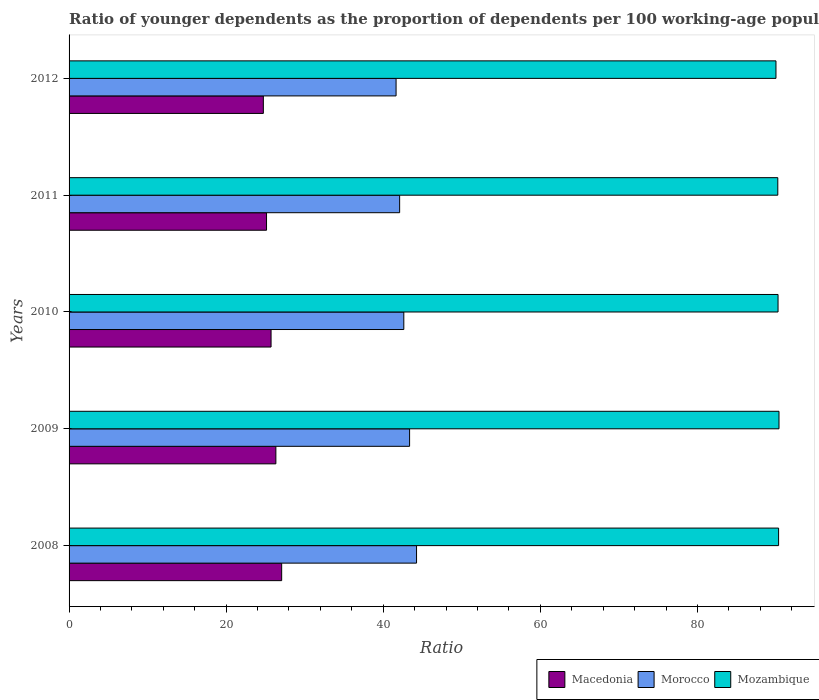How many different coloured bars are there?
Ensure brevity in your answer.  3. How many groups of bars are there?
Keep it short and to the point. 5. Are the number of bars on each tick of the Y-axis equal?
Your response must be concise. Yes. How many bars are there on the 5th tick from the top?
Ensure brevity in your answer.  3. How many bars are there on the 5th tick from the bottom?
Provide a succinct answer. 3. What is the label of the 4th group of bars from the top?
Ensure brevity in your answer.  2009. What is the age dependency ratio(young) in Mozambique in 2011?
Your answer should be compact. 90.23. Across all years, what is the maximum age dependency ratio(young) in Mozambique?
Give a very brief answer. 90.39. Across all years, what is the minimum age dependency ratio(young) in Morocco?
Provide a succinct answer. 41.63. In which year was the age dependency ratio(young) in Macedonia maximum?
Your answer should be very brief. 2008. What is the total age dependency ratio(young) in Macedonia in the graph?
Give a very brief answer. 128.99. What is the difference between the age dependency ratio(young) in Mozambique in 2009 and that in 2011?
Provide a succinct answer. 0.15. What is the difference between the age dependency ratio(young) in Macedonia in 2010 and the age dependency ratio(young) in Mozambique in 2008?
Offer a very short reply. -64.62. What is the average age dependency ratio(young) in Mozambique per year?
Offer a very short reply. 90.24. In the year 2012, what is the difference between the age dependency ratio(young) in Morocco and age dependency ratio(young) in Mozambique?
Your answer should be very brief. -48.37. What is the ratio of the age dependency ratio(young) in Macedonia in 2011 to that in 2012?
Make the answer very short. 1.02. Is the age dependency ratio(young) in Morocco in 2010 less than that in 2012?
Keep it short and to the point. No. Is the difference between the age dependency ratio(young) in Morocco in 2009 and 2010 greater than the difference between the age dependency ratio(young) in Mozambique in 2009 and 2010?
Give a very brief answer. Yes. What is the difference between the highest and the second highest age dependency ratio(young) in Morocco?
Your answer should be compact. 0.89. What is the difference between the highest and the lowest age dependency ratio(young) in Morocco?
Your response must be concise. 2.61. Is the sum of the age dependency ratio(young) in Morocco in 2008 and 2010 greater than the maximum age dependency ratio(young) in Macedonia across all years?
Your answer should be very brief. Yes. What does the 1st bar from the top in 2011 represents?
Keep it short and to the point. Mozambique. What does the 2nd bar from the bottom in 2008 represents?
Ensure brevity in your answer.  Morocco. What is the difference between two consecutive major ticks on the X-axis?
Provide a short and direct response. 20. Are the values on the major ticks of X-axis written in scientific E-notation?
Your response must be concise. No. Does the graph contain any zero values?
Provide a succinct answer. No. What is the title of the graph?
Provide a succinct answer. Ratio of younger dependents as the proportion of dependents per 100 working-age population. Does "Papua New Guinea" appear as one of the legend labels in the graph?
Ensure brevity in your answer.  No. What is the label or title of the X-axis?
Give a very brief answer. Ratio. What is the label or title of the Y-axis?
Make the answer very short. Years. What is the Ratio of Macedonia in 2008?
Your answer should be very brief. 27.07. What is the Ratio of Morocco in 2008?
Ensure brevity in your answer.  44.24. What is the Ratio in Mozambique in 2008?
Provide a succinct answer. 90.33. What is the Ratio in Macedonia in 2009?
Your answer should be very brief. 26.33. What is the Ratio in Morocco in 2009?
Your answer should be compact. 43.35. What is the Ratio in Mozambique in 2009?
Provide a succinct answer. 90.39. What is the Ratio in Macedonia in 2010?
Provide a short and direct response. 25.72. What is the Ratio of Morocco in 2010?
Offer a terse response. 42.62. What is the Ratio in Mozambique in 2010?
Provide a succinct answer. 90.27. What is the Ratio in Macedonia in 2011?
Ensure brevity in your answer.  25.14. What is the Ratio in Morocco in 2011?
Make the answer very short. 42.09. What is the Ratio of Mozambique in 2011?
Ensure brevity in your answer.  90.23. What is the Ratio of Macedonia in 2012?
Make the answer very short. 24.73. What is the Ratio of Morocco in 2012?
Give a very brief answer. 41.63. What is the Ratio in Mozambique in 2012?
Offer a terse response. 90. Across all years, what is the maximum Ratio of Macedonia?
Make the answer very short. 27.07. Across all years, what is the maximum Ratio of Morocco?
Give a very brief answer. 44.24. Across all years, what is the maximum Ratio in Mozambique?
Offer a terse response. 90.39. Across all years, what is the minimum Ratio in Macedonia?
Provide a succinct answer. 24.73. Across all years, what is the minimum Ratio in Morocco?
Provide a short and direct response. 41.63. Across all years, what is the minimum Ratio in Mozambique?
Offer a very short reply. 90. What is the total Ratio in Macedonia in the graph?
Offer a terse response. 128.99. What is the total Ratio in Morocco in the graph?
Provide a succinct answer. 213.94. What is the total Ratio in Mozambique in the graph?
Make the answer very short. 451.22. What is the difference between the Ratio in Macedonia in 2008 and that in 2009?
Make the answer very short. 0.74. What is the difference between the Ratio of Morocco in 2008 and that in 2009?
Offer a terse response. 0.89. What is the difference between the Ratio in Mozambique in 2008 and that in 2009?
Offer a terse response. -0.05. What is the difference between the Ratio of Macedonia in 2008 and that in 2010?
Offer a terse response. 1.35. What is the difference between the Ratio in Morocco in 2008 and that in 2010?
Provide a short and direct response. 1.62. What is the difference between the Ratio in Mozambique in 2008 and that in 2010?
Your answer should be very brief. 0.07. What is the difference between the Ratio of Macedonia in 2008 and that in 2011?
Make the answer very short. 1.93. What is the difference between the Ratio in Morocco in 2008 and that in 2011?
Keep it short and to the point. 2.15. What is the difference between the Ratio of Mozambique in 2008 and that in 2011?
Offer a terse response. 0.1. What is the difference between the Ratio in Macedonia in 2008 and that in 2012?
Keep it short and to the point. 2.33. What is the difference between the Ratio in Morocco in 2008 and that in 2012?
Your answer should be compact. 2.61. What is the difference between the Ratio in Mozambique in 2008 and that in 2012?
Offer a very short reply. 0.33. What is the difference between the Ratio in Macedonia in 2009 and that in 2010?
Your response must be concise. 0.61. What is the difference between the Ratio of Morocco in 2009 and that in 2010?
Your answer should be very brief. 0.74. What is the difference between the Ratio in Mozambique in 2009 and that in 2010?
Your response must be concise. 0.12. What is the difference between the Ratio of Macedonia in 2009 and that in 2011?
Offer a very short reply. 1.19. What is the difference between the Ratio in Morocco in 2009 and that in 2011?
Your answer should be compact. 1.27. What is the difference between the Ratio in Mozambique in 2009 and that in 2011?
Your answer should be very brief. 0.15. What is the difference between the Ratio in Macedonia in 2009 and that in 2012?
Provide a short and direct response. 1.6. What is the difference between the Ratio of Morocco in 2009 and that in 2012?
Your answer should be compact. 1.72. What is the difference between the Ratio of Mozambique in 2009 and that in 2012?
Ensure brevity in your answer.  0.39. What is the difference between the Ratio of Macedonia in 2010 and that in 2011?
Provide a short and direct response. 0.58. What is the difference between the Ratio of Morocco in 2010 and that in 2011?
Make the answer very short. 0.53. What is the difference between the Ratio of Mozambique in 2010 and that in 2011?
Provide a succinct answer. 0.03. What is the difference between the Ratio of Macedonia in 2010 and that in 2012?
Make the answer very short. 0.98. What is the difference between the Ratio in Morocco in 2010 and that in 2012?
Ensure brevity in your answer.  0.98. What is the difference between the Ratio of Mozambique in 2010 and that in 2012?
Ensure brevity in your answer.  0.26. What is the difference between the Ratio in Macedonia in 2011 and that in 2012?
Your response must be concise. 0.41. What is the difference between the Ratio of Morocco in 2011 and that in 2012?
Offer a very short reply. 0.45. What is the difference between the Ratio in Mozambique in 2011 and that in 2012?
Offer a terse response. 0.23. What is the difference between the Ratio in Macedonia in 2008 and the Ratio in Morocco in 2009?
Give a very brief answer. -16.29. What is the difference between the Ratio of Macedonia in 2008 and the Ratio of Mozambique in 2009?
Ensure brevity in your answer.  -63.32. What is the difference between the Ratio in Morocco in 2008 and the Ratio in Mozambique in 2009?
Ensure brevity in your answer.  -46.15. What is the difference between the Ratio of Macedonia in 2008 and the Ratio of Morocco in 2010?
Keep it short and to the point. -15.55. What is the difference between the Ratio of Macedonia in 2008 and the Ratio of Mozambique in 2010?
Your response must be concise. -63.2. What is the difference between the Ratio of Morocco in 2008 and the Ratio of Mozambique in 2010?
Offer a very short reply. -46.02. What is the difference between the Ratio of Macedonia in 2008 and the Ratio of Morocco in 2011?
Your answer should be compact. -15.02. What is the difference between the Ratio in Macedonia in 2008 and the Ratio in Mozambique in 2011?
Offer a very short reply. -63.16. What is the difference between the Ratio in Morocco in 2008 and the Ratio in Mozambique in 2011?
Your answer should be compact. -45.99. What is the difference between the Ratio in Macedonia in 2008 and the Ratio in Morocco in 2012?
Ensure brevity in your answer.  -14.56. What is the difference between the Ratio in Macedonia in 2008 and the Ratio in Mozambique in 2012?
Offer a very short reply. -62.93. What is the difference between the Ratio of Morocco in 2008 and the Ratio of Mozambique in 2012?
Your answer should be very brief. -45.76. What is the difference between the Ratio of Macedonia in 2009 and the Ratio of Morocco in 2010?
Provide a short and direct response. -16.29. What is the difference between the Ratio of Macedonia in 2009 and the Ratio of Mozambique in 2010?
Your response must be concise. -63.94. What is the difference between the Ratio in Morocco in 2009 and the Ratio in Mozambique in 2010?
Ensure brevity in your answer.  -46.91. What is the difference between the Ratio of Macedonia in 2009 and the Ratio of Morocco in 2011?
Keep it short and to the point. -15.76. What is the difference between the Ratio of Macedonia in 2009 and the Ratio of Mozambique in 2011?
Keep it short and to the point. -63.9. What is the difference between the Ratio in Morocco in 2009 and the Ratio in Mozambique in 2011?
Your answer should be compact. -46.88. What is the difference between the Ratio in Macedonia in 2009 and the Ratio in Morocco in 2012?
Your answer should be compact. -15.3. What is the difference between the Ratio in Macedonia in 2009 and the Ratio in Mozambique in 2012?
Ensure brevity in your answer.  -63.67. What is the difference between the Ratio of Morocco in 2009 and the Ratio of Mozambique in 2012?
Offer a terse response. -46.65. What is the difference between the Ratio of Macedonia in 2010 and the Ratio of Morocco in 2011?
Offer a very short reply. -16.37. What is the difference between the Ratio in Macedonia in 2010 and the Ratio in Mozambique in 2011?
Your answer should be compact. -64.52. What is the difference between the Ratio of Morocco in 2010 and the Ratio of Mozambique in 2011?
Keep it short and to the point. -47.62. What is the difference between the Ratio in Macedonia in 2010 and the Ratio in Morocco in 2012?
Ensure brevity in your answer.  -15.92. What is the difference between the Ratio in Macedonia in 2010 and the Ratio in Mozambique in 2012?
Give a very brief answer. -64.28. What is the difference between the Ratio of Morocco in 2010 and the Ratio of Mozambique in 2012?
Your answer should be compact. -47.38. What is the difference between the Ratio of Macedonia in 2011 and the Ratio of Morocco in 2012?
Make the answer very short. -16.49. What is the difference between the Ratio of Macedonia in 2011 and the Ratio of Mozambique in 2012?
Offer a very short reply. -64.86. What is the difference between the Ratio in Morocco in 2011 and the Ratio in Mozambique in 2012?
Give a very brief answer. -47.91. What is the average Ratio in Macedonia per year?
Ensure brevity in your answer.  25.8. What is the average Ratio of Morocco per year?
Offer a terse response. 42.79. What is the average Ratio in Mozambique per year?
Offer a very short reply. 90.24. In the year 2008, what is the difference between the Ratio of Macedonia and Ratio of Morocco?
Provide a short and direct response. -17.17. In the year 2008, what is the difference between the Ratio of Macedonia and Ratio of Mozambique?
Offer a terse response. -63.27. In the year 2008, what is the difference between the Ratio of Morocco and Ratio of Mozambique?
Offer a very short reply. -46.09. In the year 2009, what is the difference between the Ratio in Macedonia and Ratio in Morocco?
Make the answer very short. -17.03. In the year 2009, what is the difference between the Ratio of Macedonia and Ratio of Mozambique?
Provide a short and direct response. -64.06. In the year 2009, what is the difference between the Ratio of Morocco and Ratio of Mozambique?
Your answer should be very brief. -47.03. In the year 2010, what is the difference between the Ratio of Macedonia and Ratio of Morocco?
Your response must be concise. -16.9. In the year 2010, what is the difference between the Ratio in Macedonia and Ratio in Mozambique?
Offer a very short reply. -64.55. In the year 2010, what is the difference between the Ratio of Morocco and Ratio of Mozambique?
Your answer should be compact. -47.65. In the year 2011, what is the difference between the Ratio in Macedonia and Ratio in Morocco?
Ensure brevity in your answer.  -16.95. In the year 2011, what is the difference between the Ratio of Macedonia and Ratio of Mozambique?
Give a very brief answer. -65.09. In the year 2011, what is the difference between the Ratio in Morocco and Ratio in Mozambique?
Your response must be concise. -48.15. In the year 2012, what is the difference between the Ratio in Macedonia and Ratio in Morocco?
Provide a short and direct response. -16.9. In the year 2012, what is the difference between the Ratio of Macedonia and Ratio of Mozambique?
Offer a terse response. -65.27. In the year 2012, what is the difference between the Ratio in Morocco and Ratio in Mozambique?
Provide a short and direct response. -48.37. What is the ratio of the Ratio of Macedonia in 2008 to that in 2009?
Offer a terse response. 1.03. What is the ratio of the Ratio in Morocco in 2008 to that in 2009?
Your answer should be very brief. 1.02. What is the ratio of the Ratio of Macedonia in 2008 to that in 2010?
Your response must be concise. 1.05. What is the ratio of the Ratio in Morocco in 2008 to that in 2010?
Your answer should be very brief. 1.04. What is the ratio of the Ratio of Macedonia in 2008 to that in 2011?
Ensure brevity in your answer.  1.08. What is the ratio of the Ratio in Morocco in 2008 to that in 2011?
Keep it short and to the point. 1.05. What is the ratio of the Ratio of Mozambique in 2008 to that in 2011?
Offer a terse response. 1. What is the ratio of the Ratio of Macedonia in 2008 to that in 2012?
Keep it short and to the point. 1.09. What is the ratio of the Ratio in Morocco in 2008 to that in 2012?
Your answer should be very brief. 1.06. What is the ratio of the Ratio of Macedonia in 2009 to that in 2010?
Ensure brevity in your answer.  1.02. What is the ratio of the Ratio in Morocco in 2009 to that in 2010?
Your answer should be compact. 1.02. What is the ratio of the Ratio in Macedonia in 2009 to that in 2011?
Offer a terse response. 1.05. What is the ratio of the Ratio in Morocco in 2009 to that in 2011?
Keep it short and to the point. 1.03. What is the ratio of the Ratio in Mozambique in 2009 to that in 2011?
Make the answer very short. 1. What is the ratio of the Ratio of Macedonia in 2009 to that in 2012?
Provide a short and direct response. 1.06. What is the ratio of the Ratio of Morocco in 2009 to that in 2012?
Offer a terse response. 1.04. What is the ratio of the Ratio in Mozambique in 2009 to that in 2012?
Provide a short and direct response. 1. What is the ratio of the Ratio of Macedonia in 2010 to that in 2011?
Make the answer very short. 1.02. What is the ratio of the Ratio of Morocco in 2010 to that in 2011?
Provide a succinct answer. 1.01. What is the ratio of the Ratio in Mozambique in 2010 to that in 2011?
Offer a very short reply. 1. What is the ratio of the Ratio of Macedonia in 2010 to that in 2012?
Provide a short and direct response. 1.04. What is the ratio of the Ratio in Morocco in 2010 to that in 2012?
Your answer should be compact. 1.02. What is the ratio of the Ratio in Macedonia in 2011 to that in 2012?
Your answer should be very brief. 1.02. What is the ratio of the Ratio of Morocco in 2011 to that in 2012?
Provide a short and direct response. 1.01. What is the difference between the highest and the second highest Ratio of Macedonia?
Your answer should be compact. 0.74. What is the difference between the highest and the second highest Ratio of Morocco?
Ensure brevity in your answer.  0.89. What is the difference between the highest and the second highest Ratio in Mozambique?
Your response must be concise. 0.05. What is the difference between the highest and the lowest Ratio in Macedonia?
Ensure brevity in your answer.  2.33. What is the difference between the highest and the lowest Ratio in Morocco?
Your answer should be compact. 2.61. What is the difference between the highest and the lowest Ratio in Mozambique?
Provide a succinct answer. 0.39. 